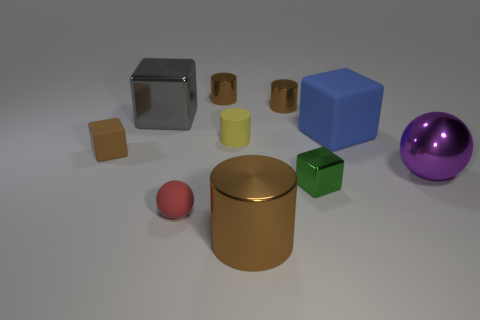How many objects are in the image, and can you categorize them by shape? There are nine objects in the image. They can be categorized by shape as follows: four cylinders, three cubes, one sphere, and one more complex shape that resembles a rectangular prism with a cutout. Could you describe the materials these objects seem to be made of? Certainly! The objects appear to be made of different materials with varying textures. The cylinders and cubes have a matte finish, suggesting a plastic or painted surface, while the sphere and the large cylinder have reflective finishes that imply they could be metallic. The object with a cutout appears to have a reflective surface as well, possibly stainless steel. 